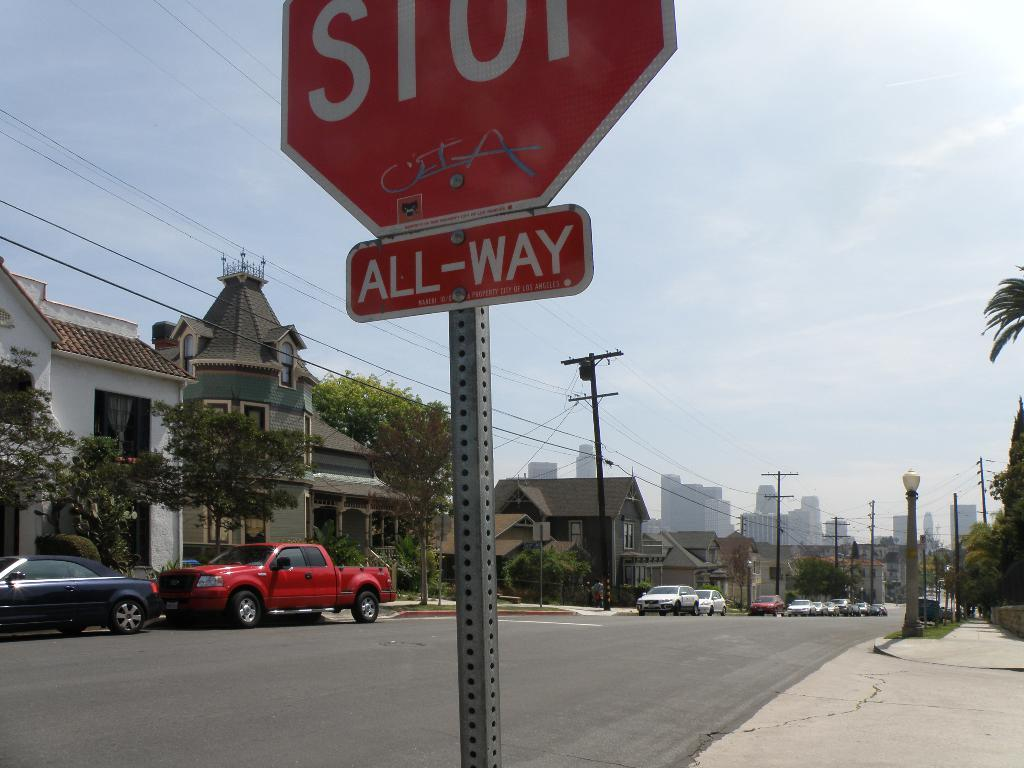<image>
Share a concise interpretation of the image provided. A red and white stop sign that also has an all way sign beneath it is on the side of the street. 